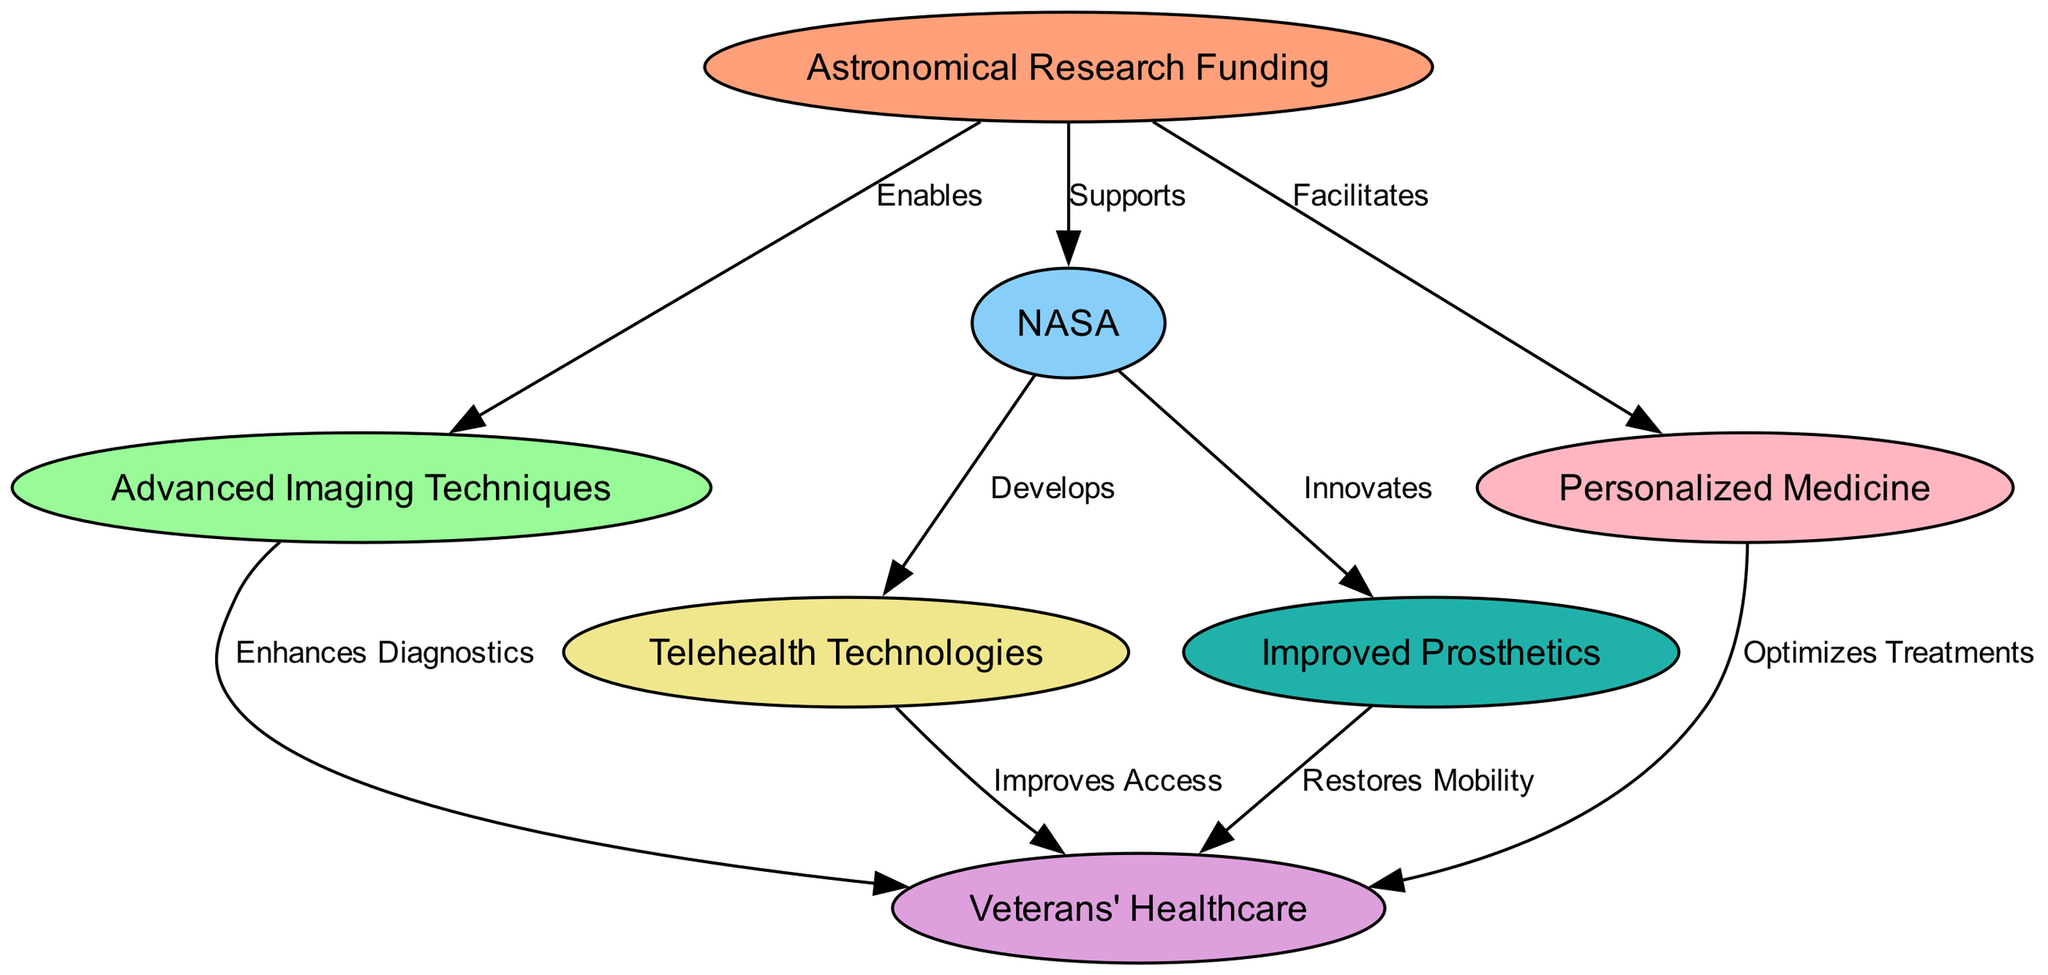What is the total number of nodes in the diagram? The diagram contains nodes representing key concepts related to astronomical research funding and veterans' healthcare. By counting the entries in the "nodes" section, there are a total of seven distinct nodes.
Answer: 7 What label connects "NASA" and "telehealth technologies"? The edge connecting "NASA" and "telehealth technologies" is labeled "Develops." This describes the relationship in the diagram indicating what NASA contributes to telehealth.
Answer: Develops Which node is directly connected to "veterans' healthcare" by "improved prosthetics"? The direct relationship indicated by the edge from "improved prosthetics" to "veterans' healthcare" is labeled "Restores Mobility," showing how improved prosthetics benefit veterans' healthcare.
Answer: Restores Mobility How does "astronomical research funding" relate to "personalized medicine"? The relationship is indicated by the label "Facilitates," showing how astronomical research funding plays a role in advancing personalized medicine.
Answer: Facilitates Which technology is developed by NASA that improves veterans' healthcare? The technology developed by NASA that contributes to improving veterans' healthcare is "telehealth technologies," linked through a direct edge labeled "Develops."
Answer: telehealth technologies What is the function of "advanced imaging techniques" in the diagram? "Advanced imaging techniques" enhances diagnostics for veterans' healthcare, indicated by the edge labeled "Enhances Diagnostics" connecting it to "veterans' healthcare."
Answer: Enhances Diagnostics Which two nodes are connected through the label "Innovates"? The nodes connected by the label "Innovates" are "NASA" and "improved prosthetics," showing how NASA's efforts lead to innovations in prosthetics for veterans.
Answer: NASA and improved prosthetics How many edges are present in the diagram? By counting the entries in the "edges" section, we find there are a total of eight edges, indicating various relationships among the nodes.
Answer: 8 What outcome does "personalized medicine" provide for veterans' healthcare? The outcome is indicated by the edge leading from "personalized medicine" to "veterans' healthcare," labeled "Optimizes Treatments." This shows the positive impact of personalized medicine on treatment strategies for veterans.
Answer: Optimizes Treatments 